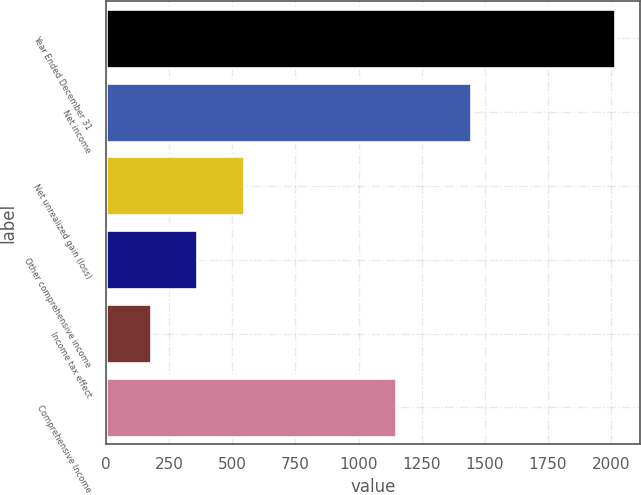Convert chart to OTSL. <chart><loc_0><loc_0><loc_500><loc_500><bar_chart><fcel>Year Ended December 31<fcel>Net income<fcel>Net unrealized gain (loss)<fcel>Other comprehensive income<fcel>Income tax effect<fcel>Comprehensive Income<nl><fcel>2015<fcel>1447<fcel>545.4<fcel>361.7<fcel>178<fcel>1148<nl></chart> 